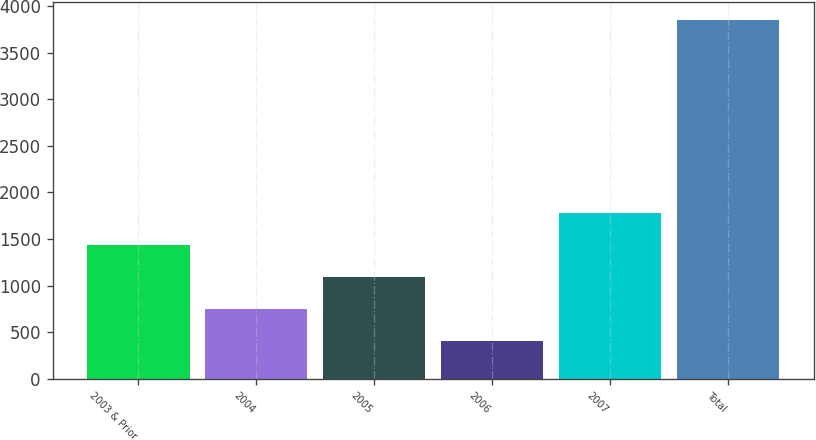Convert chart. <chart><loc_0><loc_0><loc_500><loc_500><bar_chart><fcel>2003 & Prior<fcel>2004<fcel>2005<fcel>2006<fcel>2007<fcel>Total<nl><fcel>1439.16<fcel>751.12<fcel>1095.14<fcel>407.1<fcel>1783.18<fcel>3847.3<nl></chart> 